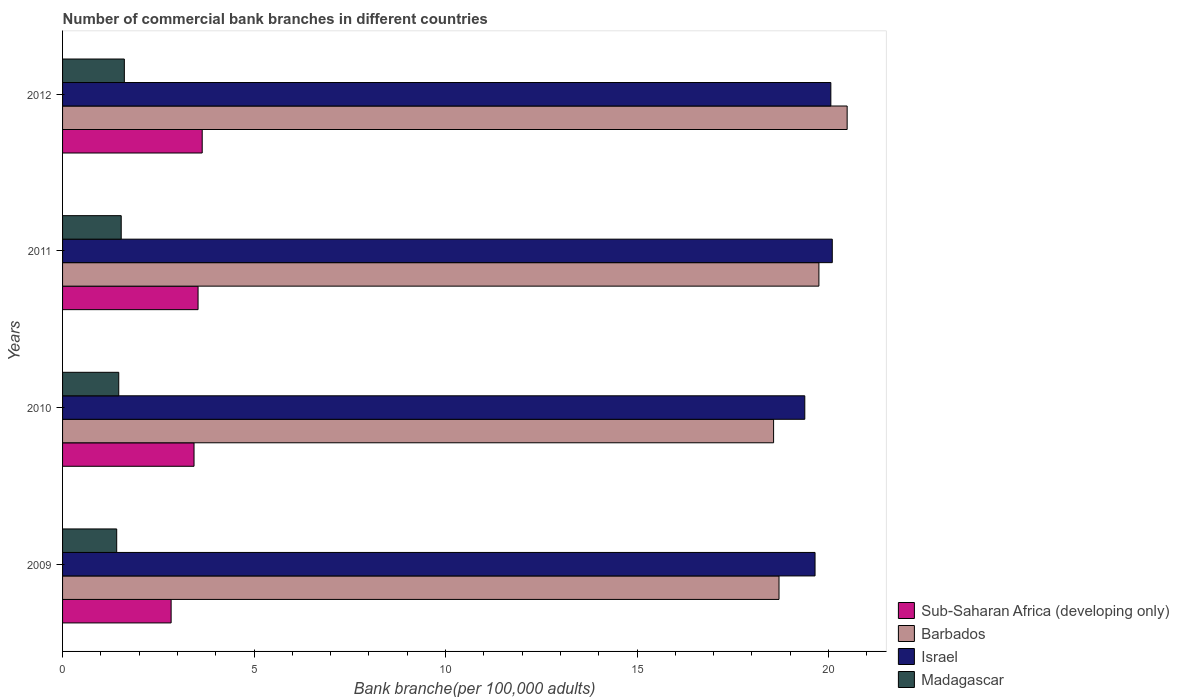How many groups of bars are there?
Keep it short and to the point. 4. Are the number of bars on each tick of the Y-axis equal?
Your answer should be compact. Yes. What is the number of commercial bank branches in Barbados in 2010?
Keep it short and to the point. 18.56. Across all years, what is the maximum number of commercial bank branches in Sub-Saharan Africa (developing only)?
Make the answer very short. 3.65. Across all years, what is the minimum number of commercial bank branches in Sub-Saharan Africa (developing only)?
Offer a terse response. 2.83. What is the total number of commercial bank branches in Israel in the graph?
Your response must be concise. 79.18. What is the difference between the number of commercial bank branches in Israel in 2010 and that in 2011?
Offer a very short reply. -0.72. What is the difference between the number of commercial bank branches in Sub-Saharan Africa (developing only) in 2010 and the number of commercial bank branches in Barbados in 2009?
Give a very brief answer. -15.27. What is the average number of commercial bank branches in Barbados per year?
Make the answer very short. 19.38. In the year 2009, what is the difference between the number of commercial bank branches in Madagascar and number of commercial bank branches in Sub-Saharan Africa (developing only)?
Offer a very short reply. -1.42. In how many years, is the number of commercial bank branches in Israel greater than 2 ?
Your response must be concise. 4. What is the ratio of the number of commercial bank branches in Israel in 2010 to that in 2012?
Offer a terse response. 0.97. Is the difference between the number of commercial bank branches in Madagascar in 2011 and 2012 greater than the difference between the number of commercial bank branches in Sub-Saharan Africa (developing only) in 2011 and 2012?
Give a very brief answer. Yes. What is the difference between the highest and the second highest number of commercial bank branches in Barbados?
Ensure brevity in your answer.  0.74. What is the difference between the highest and the lowest number of commercial bank branches in Israel?
Ensure brevity in your answer.  0.72. Is the sum of the number of commercial bank branches in Barbados in 2010 and 2011 greater than the maximum number of commercial bank branches in Sub-Saharan Africa (developing only) across all years?
Offer a terse response. Yes. What does the 1st bar from the top in 2011 represents?
Your answer should be compact. Madagascar. What does the 3rd bar from the bottom in 2010 represents?
Give a very brief answer. Israel. Is it the case that in every year, the sum of the number of commercial bank branches in Israel and number of commercial bank branches in Sub-Saharan Africa (developing only) is greater than the number of commercial bank branches in Barbados?
Make the answer very short. Yes. How many years are there in the graph?
Provide a short and direct response. 4. What is the difference between two consecutive major ticks on the X-axis?
Your answer should be very brief. 5. Does the graph contain any zero values?
Ensure brevity in your answer.  No. How are the legend labels stacked?
Ensure brevity in your answer.  Vertical. What is the title of the graph?
Make the answer very short. Number of commercial bank branches in different countries. What is the label or title of the X-axis?
Give a very brief answer. Bank branche(per 100,0 adults). What is the label or title of the Y-axis?
Offer a terse response. Years. What is the Bank branche(per 100,000 adults) in Sub-Saharan Africa (developing only) in 2009?
Make the answer very short. 2.83. What is the Bank branche(per 100,000 adults) in Barbados in 2009?
Your response must be concise. 18.71. What is the Bank branche(per 100,000 adults) of Israel in 2009?
Ensure brevity in your answer.  19.65. What is the Bank branche(per 100,000 adults) in Madagascar in 2009?
Ensure brevity in your answer.  1.41. What is the Bank branche(per 100,000 adults) in Sub-Saharan Africa (developing only) in 2010?
Your response must be concise. 3.43. What is the Bank branche(per 100,000 adults) of Barbados in 2010?
Your response must be concise. 18.56. What is the Bank branche(per 100,000 adults) in Israel in 2010?
Give a very brief answer. 19.38. What is the Bank branche(per 100,000 adults) in Madagascar in 2010?
Ensure brevity in your answer.  1.47. What is the Bank branche(per 100,000 adults) of Sub-Saharan Africa (developing only) in 2011?
Offer a very short reply. 3.54. What is the Bank branche(per 100,000 adults) of Barbados in 2011?
Give a very brief answer. 19.75. What is the Bank branche(per 100,000 adults) of Israel in 2011?
Provide a short and direct response. 20.1. What is the Bank branche(per 100,000 adults) of Madagascar in 2011?
Keep it short and to the point. 1.53. What is the Bank branche(per 100,000 adults) of Sub-Saharan Africa (developing only) in 2012?
Offer a very short reply. 3.65. What is the Bank branche(per 100,000 adults) of Barbados in 2012?
Your response must be concise. 20.49. What is the Bank branche(per 100,000 adults) of Israel in 2012?
Make the answer very short. 20.06. What is the Bank branche(per 100,000 adults) in Madagascar in 2012?
Make the answer very short. 1.61. Across all years, what is the maximum Bank branche(per 100,000 adults) of Sub-Saharan Africa (developing only)?
Give a very brief answer. 3.65. Across all years, what is the maximum Bank branche(per 100,000 adults) in Barbados?
Offer a very short reply. 20.49. Across all years, what is the maximum Bank branche(per 100,000 adults) of Israel?
Your answer should be compact. 20.1. Across all years, what is the maximum Bank branche(per 100,000 adults) of Madagascar?
Make the answer very short. 1.61. Across all years, what is the minimum Bank branche(per 100,000 adults) in Sub-Saharan Africa (developing only)?
Provide a succinct answer. 2.83. Across all years, what is the minimum Bank branche(per 100,000 adults) of Barbados?
Make the answer very short. 18.56. Across all years, what is the minimum Bank branche(per 100,000 adults) of Israel?
Provide a succinct answer. 19.38. Across all years, what is the minimum Bank branche(per 100,000 adults) in Madagascar?
Your answer should be very brief. 1.41. What is the total Bank branche(per 100,000 adults) of Sub-Saharan Africa (developing only) in the graph?
Keep it short and to the point. 13.45. What is the total Bank branche(per 100,000 adults) in Barbados in the graph?
Keep it short and to the point. 77.51. What is the total Bank branche(per 100,000 adults) in Israel in the graph?
Your response must be concise. 79.18. What is the total Bank branche(per 100,000 adults) in Madagascar in the graph?
Offer a very short reply. 6.02. What is the difference between the Bank branche(per 100,000 adults) in Sub-Saharan Africa (developing only) in 2009 and that in 2010?
Give a very brief answer. -0.6. What is the difference between the Bank branche(per 100,000 adults) in Barbados in 2009 and that in 2010?
Your answer should be compact. 0.14. What is the difference between the Bank branche(per 100,000 adults) of Israel in 2009 and that in 2010?
Provide a short and direct response. 0.27. What is the difference between the Bank branche(per 100,000 adults) of Madagascar in 2009 and that in 2010?
Offer a terse response. -0.05. What is the difference between the Bank branche(per 100,000 adults) of Sub-Saharan Africa (developing only) in 2009 and that in 2011?
Make the answer very short. -0.7. What is the difference between the Bank branche(per 100,000 adults) in Barbados in 2009 and that in 2011?
Make the answer very short. -1.04. What is the difference between the Bank branche(per 100,000 adults) in Israel in 2009 and that in 2011?
Make the answer very short. -0.45. What is the difference between the Bank branche(per 100,000 adults) in Madagascar in 2009 and that in 2011?
Offer a very short reply. -0.12. What is the difference between the Bank branche(per 100,000 adults) in Sub-Saharan Africa (developing only) in 2009 and that in 2012?
Offer a terse response. -0.81. What is the difference between the Bank branche(per 100,000 adults) in Barbados in 2009 and that in 2012?
Your response must be concise. -1.78. What is the difference between the Bank branche(per 100,000 adults) in Israel in 2009 and that in 2012?
Your response must be concise. -0.41. What is the difference between the Bank branche(per 100,000 adults) in Madagascar in 2009 and that in 2012?
Offer a terse response. -0.2. What is the difference between the Bank branche(per 100,000 adults) in Sub-Saharan Africa (developing only) in 2010 and that in 2011?
Offer a very short reply. -0.11. What is the difference between the Bank branche(per 100,000 adults) of Barbados in 2010 and that in 2011?
Give a very brief answer. -1.18. What is the difference between the Bank branche(per 100,000 adults) in Israel in 2010 and that in 2011?
Your answer should be compact. -0.72. What is the difference between the Bank branche(per 100,000 adults) in Madagascar in 2010 and that in 2011?
Your answer should be compact. -0.06. What is the difference between the Bank branche(per 100,000 adults) of Sub-Saharan Africa (developing only) in 2010 and that in 2012?
Your answer should be compact. -0.21. What is the difference between the Bank branche(per 100,000 adults) of Barbados in 2010 and that in 2012?
Keep it short and to the point. -1.92. What is the difference between the Bank branche(per 100,000 adults) in Israel in 2010 and that in 2012?
Give a very brief answer. -0.68. What is the difference between the Bank branche(per 100,000 adults) of Madagascar in 2010 and that in 2012?
Offer a very short reply. -0.15. What is the difference between the Bank branche(per 100,000 adults) of Sub-Saharan Africa (developing only) in 2011 and that in 2012?
Your answer should be very brief. -0.11. What is the difference between the Bank branche(per 100,000 adults) in Barbados in 2011 and that in 2012?
Give a very brief answer. -0.74. What is the difference between the Bank branche(per 100,000 adults) in Israel in 2011 and that in 2012?
Provide a short and direct response. 0.04. What is the difference between the Bank branche(per 100,000 adults) in Madagascar in 2011 and that in 2012?
Offer a terse response. -0.08. What is the difference between the Bank branche(per 100,000 adults) of Sub-Saharan Africa (developing only) in 2009 and the Bank branche(per 100,000 adults) of Barbados in 2010?
Offer a terse response. -15.73. What is the difference between the Bank branche(per 100,000 adults) in Sub-Saharan Africa (developing only) in 2009 and the Bank branche(per 100,000 adults) in Israel in 2010?
Offer a very short reply. -16.55. What is the difference between the Bank branche(per 100,000 adults) in Sub-Saharan Africa (developing only) in 2009 and the Bank branche(per 100,000 adults) in Madagascar in 2010?
Give a very brief answer. 1.37. What is the difference between the Bank branche(per 100,000 adults) of Barbados in 2009 and the Bank branche(per 100,000 adults) of Israel in 2010?
Offer a terse response. -0.67. What is the difference between the Bank branche(per 100,000 adults) of Barbados in 2009 and the Bank branche(per 100,000 adults) of Madagascar in 2010?
Provide a short and direct response. 17.24. What is the difference between the Bank branche(per 100,000 adults) in Israel in 2009 and the Bank branche(per 100,000 adults) in Madagascar in 2010?
Offer a terse response. 18.18. What is the difference between the Bank branche(per 100,000 adults) in Sub-Saharan Africa (developing only) in 2009 and the Bank branche(per 100,000 adults) in Barbados in 2011?
Your answer should be compact. -16.91. What is the difference between the Bank branche(per 100,000 adults) of Sub-Saharan Africa (developing only) in 2009 and the Bank branche(per 100,000 adults) of Israel in 2011?
Keep it short and to the point. -17.26. What is the difference between the Bank branche(per 100,000 adults) in Sub-Saharan Africa (developing only) in 2009 and the Bank branche(per 100,000 adults) in Madagascar in 2011?
Ensure brevity in your answer.  1.3. What is the difference between the Bank branche(per 100,000 adults) of Barbados in 2009 and the Bank branche(per 100,000 adults) of Israel in 2011?
Make the answer very short. -1.39. What is the difference between the Bank branche(per 100,000 adults) in Barbados in 2009 and the Bank branche(per 100,000 adults) in Madagascar in 2011?
Give a very brief answer. 17.18. What is the difference between the Bank branche(per 100,000 adults) in Israel in 2009 and the Bank branche(per 100,000 adults) in Madagascar in 2011?
Your answer should be very brief. 18.12. What is the difference between the Bank branche(per 100,000 adults) of Sub-Saharan Africa (developing only) in 2009 and the Bank branche(per 100,000 adults) of Barbados in 2012?
Your response must be concise. -17.65. What is the difference between the Bank branche(per 100,000 adults) in Sub-Saharan Africa (developing only) in 2009 and the Bank branche(per 100,000 adults) in Israel in 2012?
Your response must be concise. -17.23. What is the difference between the Bank branche(per 100,000 adults) of Sub-Saharan Africa (developing only) in 2009 and the Bank branche(per 100,000 adults) of Madagascar in 2012?
Your answer should be very brief. 1.22. What is the difference between the Bank branche(per 100,000 adults) of Barbados in 2009 and the Bank branche(per 100,000 adults) of Israel in 2012?
Offer a terse response. -1.35. What is the difference between the Bank branche(per 100,000 adults) of Barbados in 2009 and the Bank branche(per 100,000 adults) of Madagascar in 2012?
Your response must be concise. 17.09. What is the difference between the Bank branche(per 100,000 adults) in Israel in 2009 and the Bank branche(per 100,000 adults) in Madagascar in 2012?
Provide a succinct answer. 18.03. What is the difference between the Bank branche(per 100,000 adults) in Sub-Saharan Africa (developing only) in 2010 and the Bank branche(per 100,000 adults) in Barbados in 2011?
Make the answer very short. -16.32. What is the difference between the Bank branche(per 100,000 adults) of Sub-Saharan Africa (developing only) in 2010 and the Bank branche(per 100,000 adults) of Israel in 2011?
Your answer should be compact. -16.66. What is the difference between the Bank branche(per 100,000 adults) of Sub-Saharan Africa (developing only) in 2010 and the Bank branche(per 100,000 adults) of Madagascar in 2011?
Provide a short and direct response. 1.9. What is the difference between the Bank branche(per 100,000 adults) of Barbados in 2010 and the Bank branche(per 100,000 adults) of Israel in 2011?
Keep it short and to the point. -1.53. What is the difference between the Bank branche(per 100,000 adults) in Barbados in 2010 and the Bank branche(per 100,000 adults) in Madagascar in 2011?
Your response must be concise. 17.03. What is the difference between the Bank branche(per 100,000 adults) in Israel in 2010 and the Bank branche(per 100,000 adults) in Madagascar in 2011?
Offer a terse response. 17.85. What is the difference between the Bank branche(per 100,000 adults) of Sub-Saharan Africa (developing only) in 2010 and the Bank branche(per 100,000 adults) of Barbados in 2012?
Your response must be concise. -17.05. What is the difference between the Bank branche(per 100,000 adults) in Sub-Saharan Africa (developing only) in 2010 and the Bank branche(per 100,000 adults) in Israel in 2012?
Make the answer very short. -16.63. What is the difference between the Bank branche(per 100,000 adults) of Sub-Saharan Africa (developing only) in 2010 and the Bank branche(per 100,000 adults) of Madagascar in 2012?
Keep it short and to the point. 1.82. What is the difference between the Bank branche(per 100,000 adults) of Barbados in 2010 and the Bank branche(per 100,000 adults) of Israel in 2012?
Make the answer very short. -1.49. What is the difference between the Bank branche(per 100,000 adults) in Barbados in 2010 and the Bank branche(per 100,000 adults) in Madagascar in 2012?
Offer a very short reply. 16.95. What is the difference between the Bank branche(per 100,000 adults) in Israel in 2010 and the Bank branche(per 100,000 adults) in Madagascar in 2012?
Your response must be concise. 17.77. What is the difference between the Bank branche(per 100,000 adults) of Sub-Saharan Africa (developing only) in 2011 and the Bank branche(per 100,000 adults) of Barbados in 2012?
Offer a very short reply. -16.95. What is the difference between the Bank branche(per 100,000 adults) in Sub-Saharan Africa (developing only) in 2011 and the Bank branche(per 100,000 adults) in Israel in 2012?
Make the answer very short. -16.52. What is the difference between the Bank branche(per 100,000 adults) in Sub-Saharan Africa (developing only) in 2011 and the Bank branche(per 100,000 adults) in Madagascar in 2012?
Your answer should be very brief. 1.92. What is the difference between the Bank branche(per 100,000 adults) of Barbados in 2011 and the Bank branche(per 100,000 adults) of Israel in 2012?
Offer a terse response. -0.31. What is the difference between the Bank branche(per 100,000 adults) of Barbados in 2011 and the Bank branche(per 100,000 adults) of Madagascar in 2012?
Provide a short and direct response. 18.14. What is the difference between the Bank branche(per 100,000 adults) in Israel in 2011 and the Bank branche(per 100,000 adults) in Madagascar in 2012?
Offer a terse response. 18.48. What is the average Bank branche(per 100,000 adults) in Sub-Saharan Africa (developing only) per year?
Your answer should be very brief. 3.36. What is the average Bank branche(per 100,000 adults) in Barbados per year?
Provide a short and direct response. 19.38. What is the average Bank branche(per 100,000 adults) in Israel per year?
Your answer should be very brief. 19.8. What is the average Bank branche(per 100,000 adults) in Madagascar per year?
Keep it short and to the point. 1.51. In the year 2009, what is the difference between the Bank branche(per 100,000 adults) in Sub-Saharan Africa (developing only) and Bank branche(per 100,000 adults) in Barbados?
Provide a short and direct response. -15.87. In the year 2009, what is the difference between the Bank branche(per 100,000 adults) in Sub-Saharan Africa (developing only) and Bank branche(per 100,000 adults) in Israel?
Make the answer very short. -16.81. In the year 2009, what is the difference between the Bank branche(per 100,000 adults) of Sub-Saharan Africa (developing only) and Bank branche(per 100,000 adults) of Madagascar?
Your answer should be very brief. 1.42. In the year 2009, what is the difference between the Bank branche(per 100,000 adults) in Barbados and Bank branche(per 100,000 adults) in Israel?
Provide a succinct answer. -0.94. In the year 2009, what is the difference between the Bank branche(per 100,000 adults) in Barbados and Bank branche(per 100,000 adults) in Madagascar?
Your answer should be compact. 17.29. In the year 2009, what is the difference between the Bank branche(per 100,000 adults) in Israel and Bank branche(per 100,000 adults) in Madagascar?
Provide a short and direct response. 18.23. In the year 2010, what is the difference between the Bank branche(per 100,000 adults) of Sub-Saharan Africa (developing only) and Bank branche(per 100,000 adults) of Barbados?
Your answer should be compact. -15.13. In the year 2010, what is the difference between the Bank branche(per 100,000 adults) in Sub-Saharan Africa (developing only) and Bank branche(per 100,000 adults) in Israel?
Give a very brief answer. -15.95. In the year 2010, what is the difference between the Bank branche(per 100,000 adults) in Sub-Saharan Africa (developing only) and Bank branche(per 100,000 adults) in Madagascar?
Offer a terse response. 1.97. In the year 2010, what is the difference between the Bank branche(per 100,000 adults) in Barbados and Bank branche(per 100,000 adults) in Israel?
Make the answer very short. -0.81. In the year 2010, what is the difference between the Bank branche(per 100,000 adults) in Barbados and Bank branche(per 100,000 adults) in Madagascar?
Ensure brevity in your answer.  17.1. In the year 2010, what is the difference between the Bank branche(per 100,000 adults) in Israel and Bank branche(per 100,000 adults) in Madagascar?
Make the answer very short. 17.91. In the year 2011, what is the difference between the Bank branche(per 100,000 adults) in Sub-Saharan Africa (developing only) and Bank branche(per 100,000 adults) in Barbados?
Give a very brief answer. -16.21. In the year 2011, what is the difference between the Bank branche(per 100,000 adults) in Sub-Saharan Africa (developing only) and Bank branche(per 100,000 adults) in Israel?
Your answer should be compact. -16.56. In the year 2011, what is the difference between the Bank branche(per 100,000 adults) in Sub-Saharan Africa (developing only) and Bank branche(per 100,000 adults) in Madagascar?
Ensure brevity in your answer.  2.01. In the year 2011, what is the difference between the Bank branche(per 100,000 adults) of Barbados and Bank branche(per 100,000 adults) of Israel?
Provide a short and direct response. -0.35. In the year 2011, what is the difference between the Bank branche(per 100,000 adults) of Barbados and Bank branche(per 100,000 adults) of Madagascar?
Give a very brief answer. 18.22. In the year 2011, what is the difference between the Bank branche(per 100,000 adults) of Israel and Bank branche(per 100,000 adults) of Madagascar?
Offer a very short reply. 18.57. In the year 2012, what is the difference between the Bank branche(per 100,000 adults) in Sub-Saharan Africa (developing only) and Bank branche(per 100,000 adults) in Barbados?
Give a very brief answer. -16.84. In the year 2012, what is the difference between the Bank branche(per 100,000 adults) of Sub-Saharan Africa (developing only) and Bank branche(per 100,000 adults) of Israel?
Provide a short and direct response. -16.41. In the year 2012, what is the difference between the Bank branche(per 100,000 adults) of Sub-Saharan Africa (developing only) and Bank branche(per 100,000 adults) of Madagascar?
Make the answer very short. 2.03. In the year 2012, what is the difference between the Bank branche(per 100,000 adults) of Barbados and Bank branche(per 100,000 adults) of Israel?
Keep it short and to the point. 0.43. In the year 2012, what is the difference between the Bank branche(per 100,000 adults) in Barbados and Bank branche(per 100,000 adults) in Madagascar?
Provide a short and direct response. 18.87. In the year 2012, what is the difference between the Bank branche(per 100,000 adults) in Israel and Bank branche(per 100,000 adults) in Madagascar?
Your answer should be compact. 18.45. What is the ratio of the Bank branche(per 100,000 adults) of Sub-Saharan Africa (developing only) in 2009 to that in 2010?
Offer a terse response. 0.83. What is the ratio of the Bank branche(per 100,000 adults) of Barbados in 2009 to that in 2010?
Your answer should be compact. 1.01. What is the ratio of the Bank branche(per 100,000 adults) of Israel in 2009 to that in 2010?
Keep it short and to the point. 1.01. What is the ratio of the Bank branche(per 100,000 adults) in Madagascar in 2009 to that in 2010?
Ensure brevity in your answer.  0.96. What is the ratio of the Bank branche(per 100,000 adults) of Sub-Saharan Africa (developing only) in 2009 to that in 2011?
Give a very brief answer. 0.8. What is the ratio of the Bank branche(per 100,000 adults) in Barbados in 2009 to that in 2011?
Offer a very short reply. 0.95. What is the ratio of the Bank branche(per 100,000 adults) in Israel in 2009 to that in 2011?
Your answer should be compact. 0.98. What is the ratio of the Bank branche(per 100,000 adults) in Madagascar in 2009 to that in 2011?
Ensure brevity in your answer.  0.92. What is the ratio of the Bank branche(per 100,000 adults) of Sub-Saharan Africa (developing only) in 2009 to that in 2012?
Provide a succinct answer. 0.78. What is the ratio of the Bank branche(per 100,000 adults) in Barbados in 2009 to that in 2012?
Ensure brevity in your answer.  0.91. What is the ratio of the Bank branche(per 100,000 adults) of Israel in 2009 to that in 2012?
Make the answer very short. 0.98. What is the ratio of the Bank branche(per 100,000 adults) in Madagascar in 2009 to that in 2012?
Provide a short and direct response. 0.88. What is the ratio of the Bank branche(per 100,000 adults) in Sub-Saharan Africa (developing only) in 2010 to that in 2011?
Make the answer very short. 0.97. What is the ratio of the Bank branche(per 100,000 adults) in Barbados in 2010 to that in 2011?
Your response must be concise. 0.94. What is the ratio of the Bank branche(per 100,000 adults) of Israel in 2010 to that in 2011?
Your response must be concise. 0.96. What is the ratio of the Bank branche(per 100,000 adults) of Madagascar in 2010 to that in 2011?
Your answer should be compact. 0.96. What is the ratio of the Bank branche(per 100,000 adults) of Sub-Saharan Africa (developing only) in 2010 to that in 2012?
Your answer should be compact. 0.94. What is the ratio of the Bank branche(per 100,000 adults) of Barbados in 2010 to that in 2012?
Give a very brief answer. 0.91. What is the ratio of the Bank branche(per 100,000 adults) in Israel in 2010 to that in 2012?
Ensure brevity in your answer.  0.97. What is the ratio of the Bank branche(per 100,000 adults) in Madagascar in 2010 to that in 2012?
Keep it short and to the point. 0.91. What is the ratio of the Bank branche(per 100,000 adults) of Sub-Saharan Africa (developing only) in 2011 to that in 2012?
Provide a succinct answer. 0.97. What is the ratio of the Bank branche(per 100,000 adults) in Barbados in 2011 to that in 2012?
Provide a short and direct response. 0.96. What is the ratio of the Bank branche(per 100,000 adults) of Israel in 2011 to that in 2012?
Ensure brevity in your answer.  1. What is the ratio of the Bank branche(per 100,000 adults) of Madagascar in 2011 to that in 2012?
Offer a very short reply. 0.95. What is the difference between the highest and the second highest Bank branche(per 100,000 adults) of Sub-Saharan Africa (developing only)?
Provide a succinct answer. 0.11. What is the difference between the highest and the second highest Bank branche(per 100,000 adults) of Barbados?
Provide a succinct answer. 0.74. What is the difference between the highest and the second highest Bank branche(per 100,000 adults) in Israel?
Your answer should be compact. 0.04. What is the difference between the highest and the second highest Bank branche(per 100,000 adults) in Madagascar?
Your answer should be very brief. 0.08. What is the difference between the highest and the lowest Bank branche(per 100,000 adults) of Sub-Saharan Africa (developing only)?
Offer a terse response. 0.81. What is the difference between the highest and the lowest Bank branche(per 100,000 adults) of Barbados?
Your response must be concise. 1.92. What is the difference between the highest and the lowest Bank branche(per 100,000 adults) in Israel?
Your answer should be very brief. 0.72. What is the difference between the highest and the lowest Bank branche(per 100,000 adults) in Madagascar?
Your answer should be very brief. 0.2. 